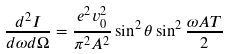<formula> <loc_0><loc_0><loc_500><loc_500>\frac { d ^ { 2 } I } { d \omega d \Omega } = \frac { e ^ { 2 } v _ { 0 } ^ { 2 } } { \pi ^ { 2 } A ^ { 2 } } \sin ^ { 2 } \theta \sin ^ { 2 } \frac { \omega A T } { 2 }</formula> 